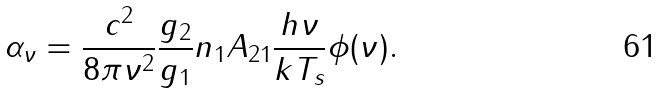<formula> <loc_0><loc_0><loc_500><loc_500>\alpha _ { \nu } = \frac { c ^ { 2 } } { 8 \pi \nu ^ { 2 } } \frac { g _ { 2 } } { g _ { 1 } } n _ { 1 } A _ { 2 1 } \frac { h \nu } { k T _ { s } } \phi ( \nu ) .</formula> 